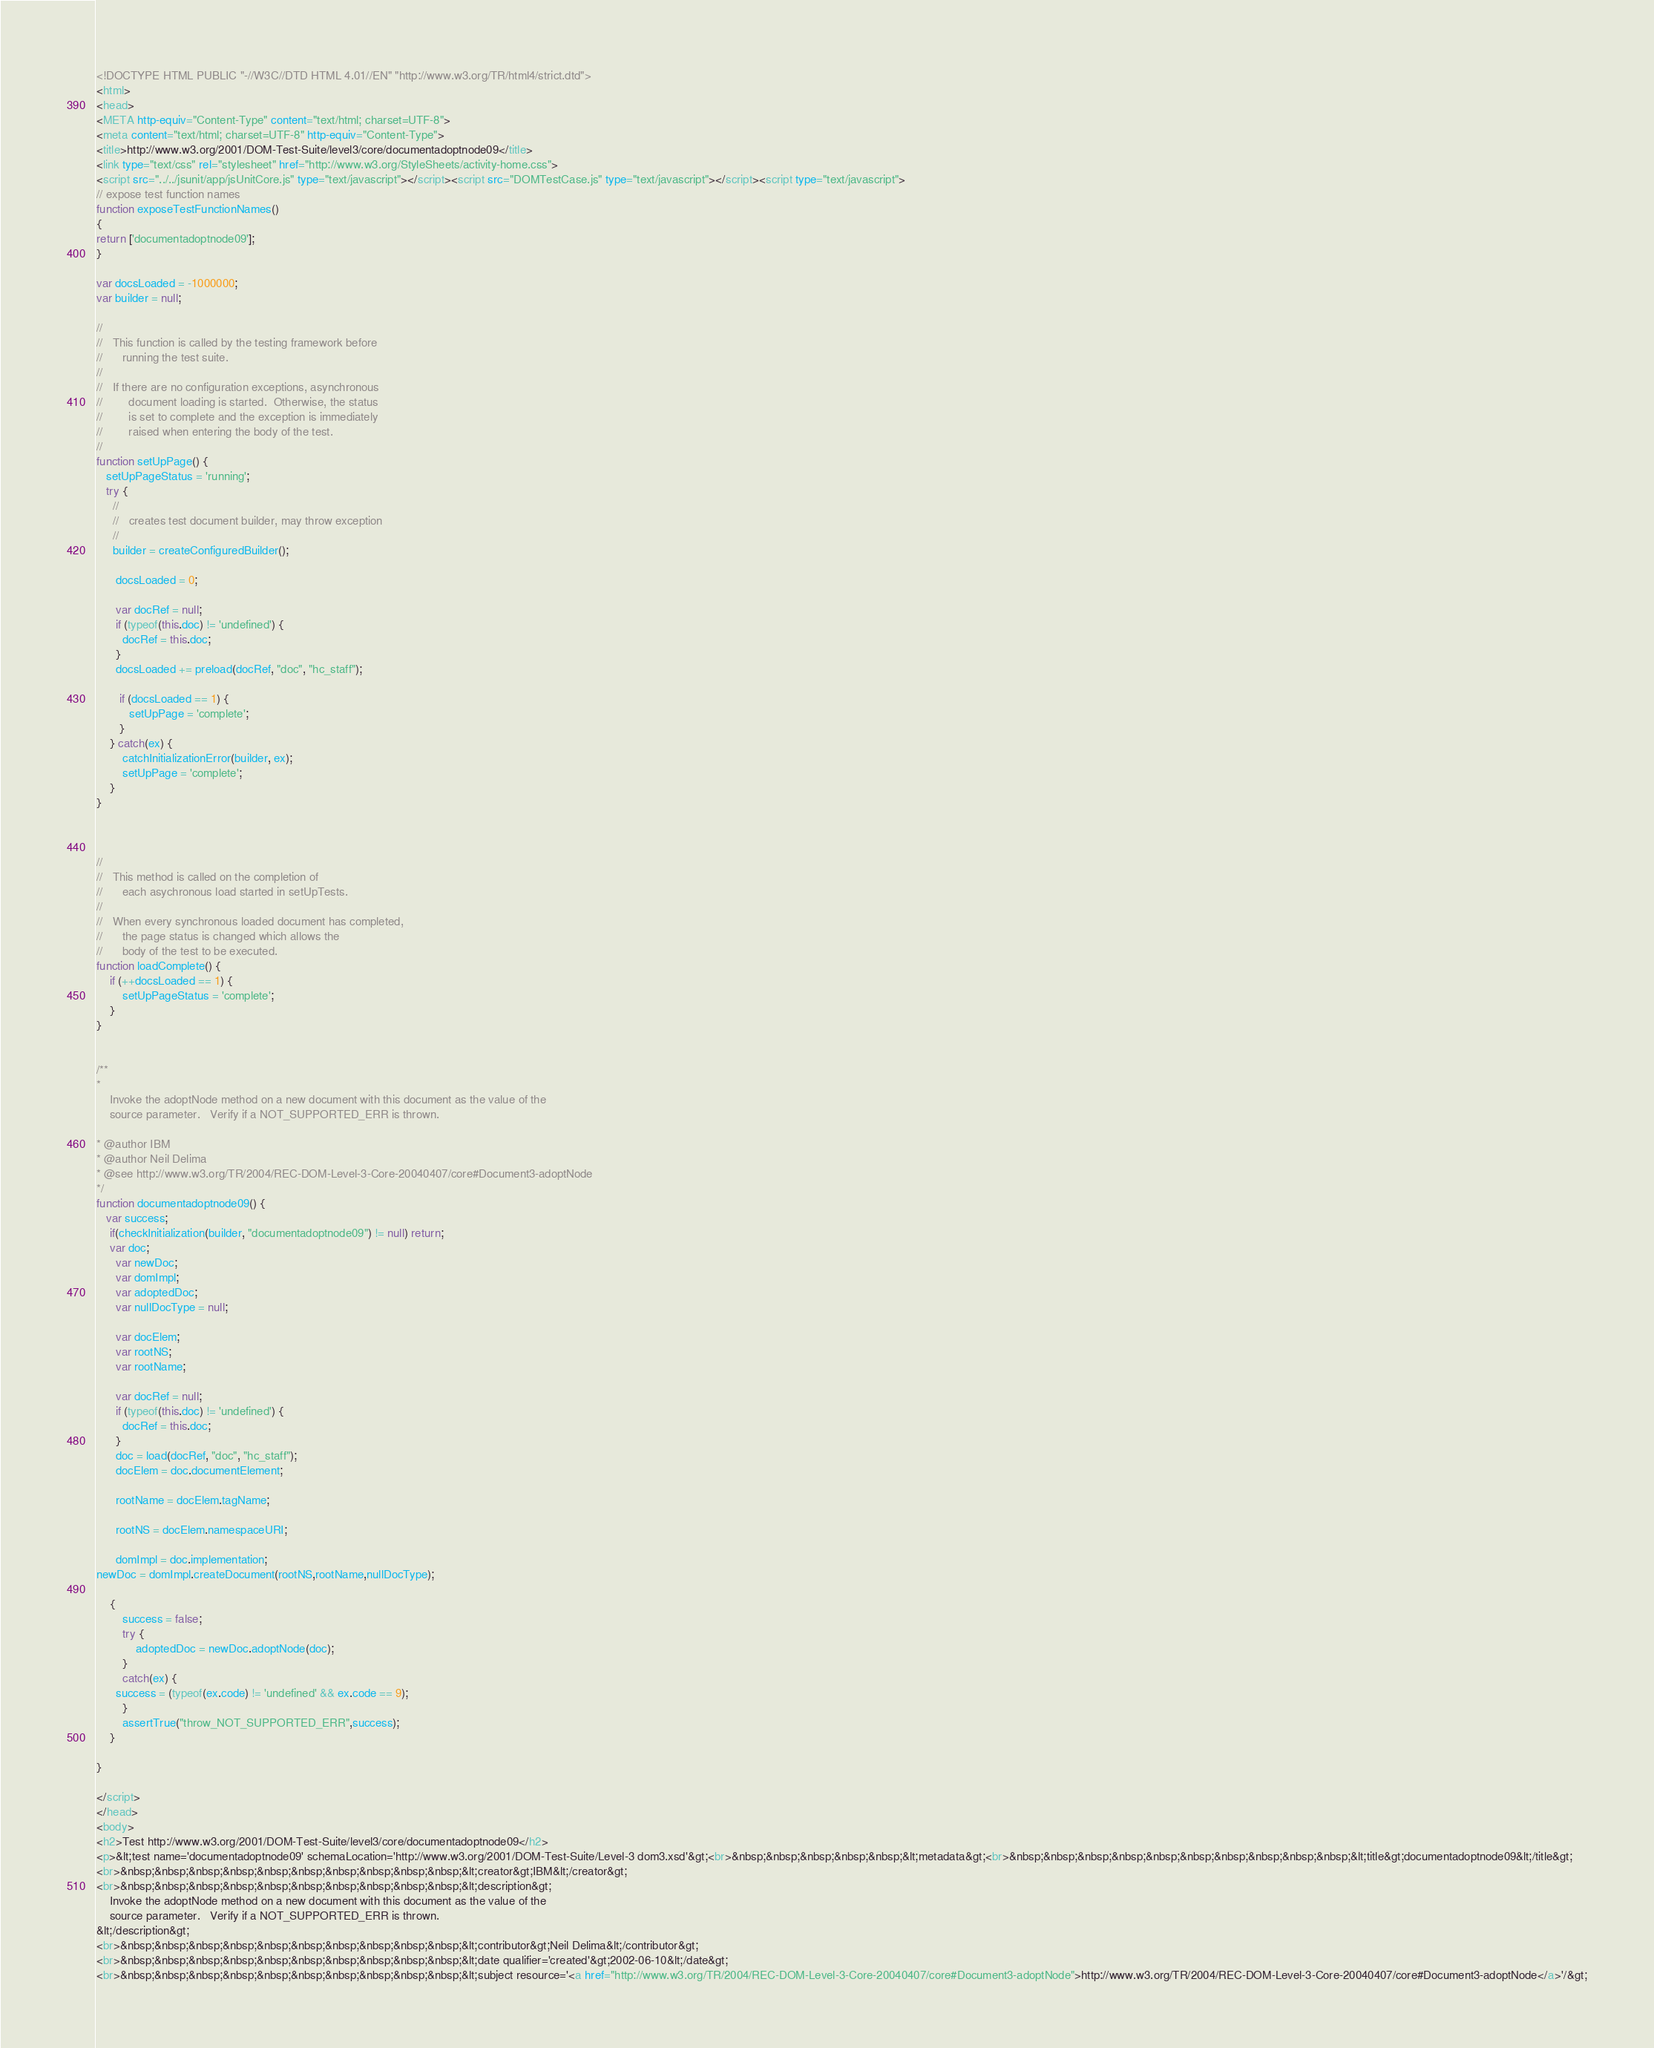Convert code to text. <code><loc_0><loc_0><loc_500><loc_500><_HTML_><!DOCTYPE HTML PUBLIC "-//W3C//DTD HTML 4.01//EN" "http://www.w3.org/TR/html4/strict.dtd">
<html>
<head>
<META http-equiv="Content-Type" content="text/html; charset=UTF-8">
<meta content="text/html; charset=UTF-8" http-equiv="Content-Type">
<title>http://www.w3.org/2001/DOM-Test-Suite/level3/core/documentadoptnode09</title>
<link type="text/css" rel="stylesheet" href="http://www.w3.org/StyleSheets/activity-home.css">
<script src="../../jsunit/app/jsUnitCore.js" type="text/javascript"></script><script src="DOMTestCase.js" type="text/javascript"></script><script type="text/javascript">
// expose test function names
function exposeTestFunctionNames()
{
return ['documentadoptnode09'];
}

var docsLoaded = -1000000;
var builder = null;

//
//   This function is called by the testing framework before
//      running the test suite.
//
//   If there are no configuration exceptions, asynchronous
//        document loading is started.  Otherwise, the status
//        is set to complete and the exception is immediately
//        raised when entering the body of the test.
//
function setUpPage() {
   setUpPageStatus = 'running';
   try {
     //
     //   creates test document builder, may throw exception
     //
     builder = createConfiguredBuilder();

      docsLoaded = 0;
      
      var docRef = null;
      if (typeof(this.doc) != 'undefined') {
        docRef = this.doc;
      }
      docsLoaded += preload(docRef, "doc", "hc_staff");
        
       if (docsLoaded == 1) {
          setUpPage = 'complete';
       }
    } catch(ex) {
    	catchInitializationError(builder, ex);
        setUpPage = 'complete';
    }
}



//
//   This method is called on the completion of 
//      each asychronous load started in setUpTests.
//
//   When every synchronous loaded document has completed,
//      the page status is changed which allows the
//      body of the test to be executed.
function loadComplete() {
    if (++docsLoaded == 1) {
        setUpPageStatus = 'complete';
    }
}


/**
* 
	Invoke the adoptNode method on a new document with this document as the value of the 
	source parameter. 	Verify if a NOT_SUPPORTED_ERR is thrown.

* @author IBM
* @author Neil Delima
* @see http://www.w3.org/TR/2004/REC-DOM-Level-3-Core-20040407/core#Document3-adoptNode
*/
function documentadoptnode09() {
   var success;
    if(checkInitialization(builder, "documentadoptnode09") != null) return;
    var doc;
      var newDoc;
      var domImpl;
      var adoptedDoc;
      var nullDocType = null;

      var docElem;
      var rootNS;
      var rootName;
      
      var docRef = null;
      if (typeof(this.doc) != 'undefined') {
        docRef = this.doc;
      }
      doc = load(docRef, "doc", "hc_staff");
      docElem = doc.documentElement;

      rootName = docElem.tagName;

      rootNS = docElem.namespaceURI;

      domImpl = doc.implementation;
newDoc = domImpl.createDocument(rootNS,rootName,nullDocType);
      
	{
		success = false;
		try {
            adoptedDoc = newDoc.adoptNode(doc);
        }
		catch(ex) {
      success = (typeof(ex.code) != 'undefined' && ex.code == 9);
		}
		assertTrue("throw_NOT_SUPPORTED_ERR",success);
	}

}

</script>
</head>
<body>
<h2>Test http://www.w3.org/2001/DOM-Test-Suite/level3/core/documentadoptnode09</h2>
<p>&lt;test name='documentadoptnode09' schemaLocation='http://www.w3.org/2001/DOM-Test-Suite/Level-3 dom3.xsd'&gt;<br>&nbsp;&nbsp;&nbsp;&nbsp;&nbsp;&lt;metadata&gt;<br>&nbsp;&nbsp;&nbsp;&nbsp;&nbsp;&nbsp;&nbsp;&nbsp;&nbsp;&nbsp;&lt;title&gt;documentadoptnode09&lt;/title&gt;
<br>&nbsp;&nbsp;&nbsp;&nbsp;&nbsp;&nbsp;&nbsp;&nbsp;&nbsp;&nbsp;&lt;creator&gt;IBM&lt;/creator&gt;
<br>&nbsp;&nbsp;&nbsp;&nbsp;&nbsp;&nbsp;&nbsp;&nbsp;&nbsp;&nbsp;&lt;description&gt;
	Invoke the adoptNode method on a new document with this document as the value of the 
	source parameter. 	Verify if a NOT_SUPPORTED_ERR is thrown.
&lt;/description&gt;
<br>&nbsp;&nbsp;&nbsp;&nbsp;&nbsp;&nbsp;&nbsp;&nbsp;&nbsp;&nbsp;&lt;contributor&gt;Neil Delima&lt;/contributor&gt;
<br>&nbsp;&nbsp;&nbsp;&nbsp;&nbsp;&nbsp;&nbsp;&nbsp;&nbsp;&nbsp;&lt;date qualifier='created'&gt;2002-06-10&lt;/date&gt;
<br>&nbsp;&nbsp;&nbsp;&nbsp;&nbsp;&nbsp;&nbsp;&nbsp;&nbsp;&nbsp;&lt;subject resource='<a href="http://www.w3.org/TR/2004/REC-DOM-Level-3-Core-20040407/core#Document3-adoptNode">http://www.w3.org/TR/2004/REC-DOM-Level-3-Core-20040407/core#Document3-adoptNode</a>'/&gt;</code> 